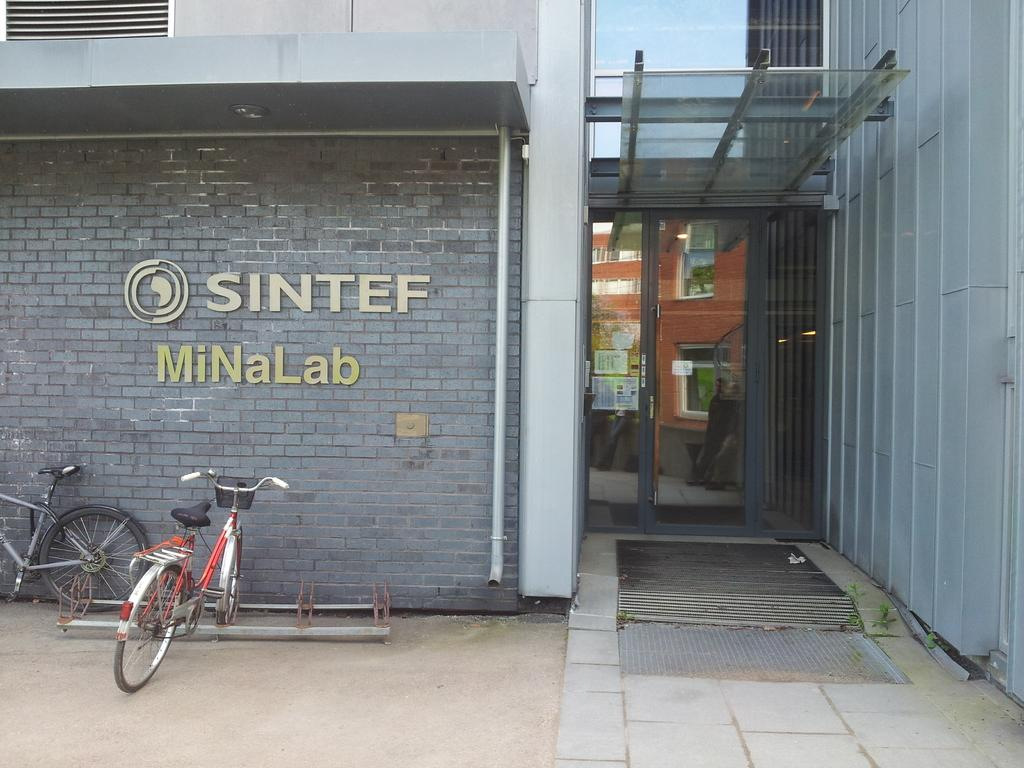What type of vehicles are in the image? There are bicycles in the image. What can be seen on the ground in the image? There are objects on the ground in the image. What is visible in the background of the image? There is a wall, doors, people, posters, and other objects in the background of the image. Where is the desk located in the image? There is no desk present in the image. What type of writing instrument is being used by the people in the image? The image does not show any writing instruments being used by the people. 